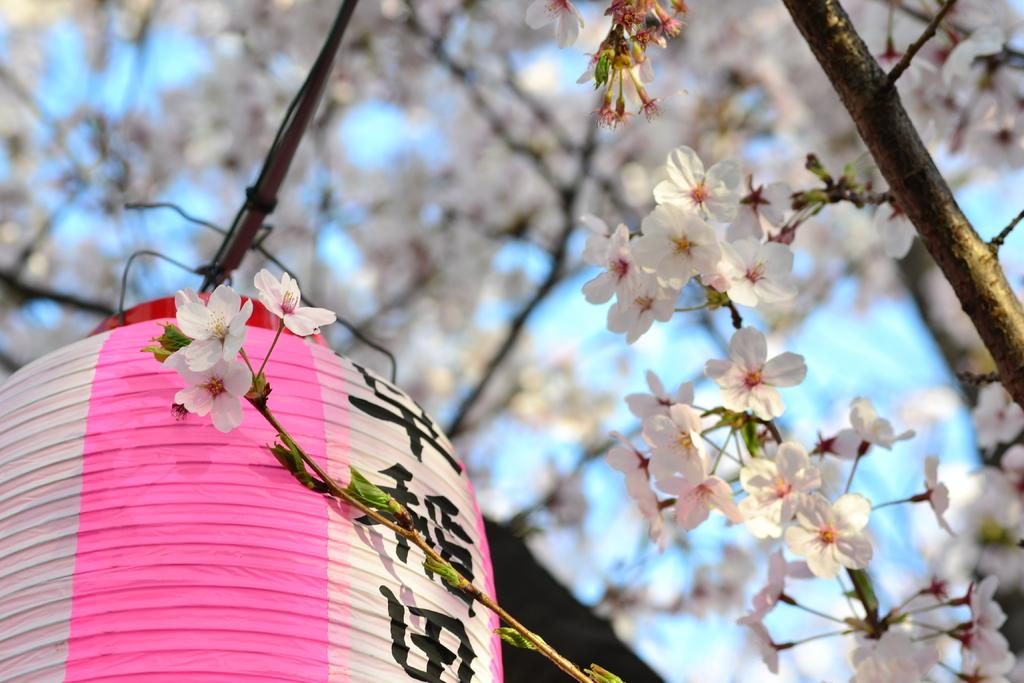What type of plants can be seen in the image? There are flowers in the image. What object is present in the image that provides light? There is a lantern in the image. How would you describe the background of the image? The background of the image is blurred. How does the beggar in the image fold the stretch of fabric? There is no beggar or stretch of fabric present in the image; it features flowers and a lantern. 